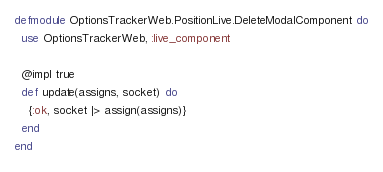<code> <loc_0><loc_0><loc_500><loc_500><_Elixir_>defmodule OptionsTrackerWeb.PositionLive.DeleteModalComponent do
  use OptionsTrackerWeb, :live_component

  @impl true
  def update(assigns, socket) do
    {:ok, socket |> assign(assigns)}
  end
end
</code> 